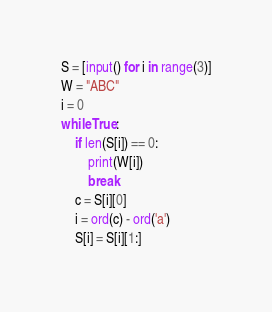<code> <loc_0><loc_0><loc_500><loc_500><_Python_>S = [input() for i in range(3)]
W = "ABC"
i = 0
while True:
    if len(S[i]) == 0:
        print(W[i])
        break
    c = S[i][0]
    i = ord(c) - ord('a')
    S[i] = S[i][1:]</code> 